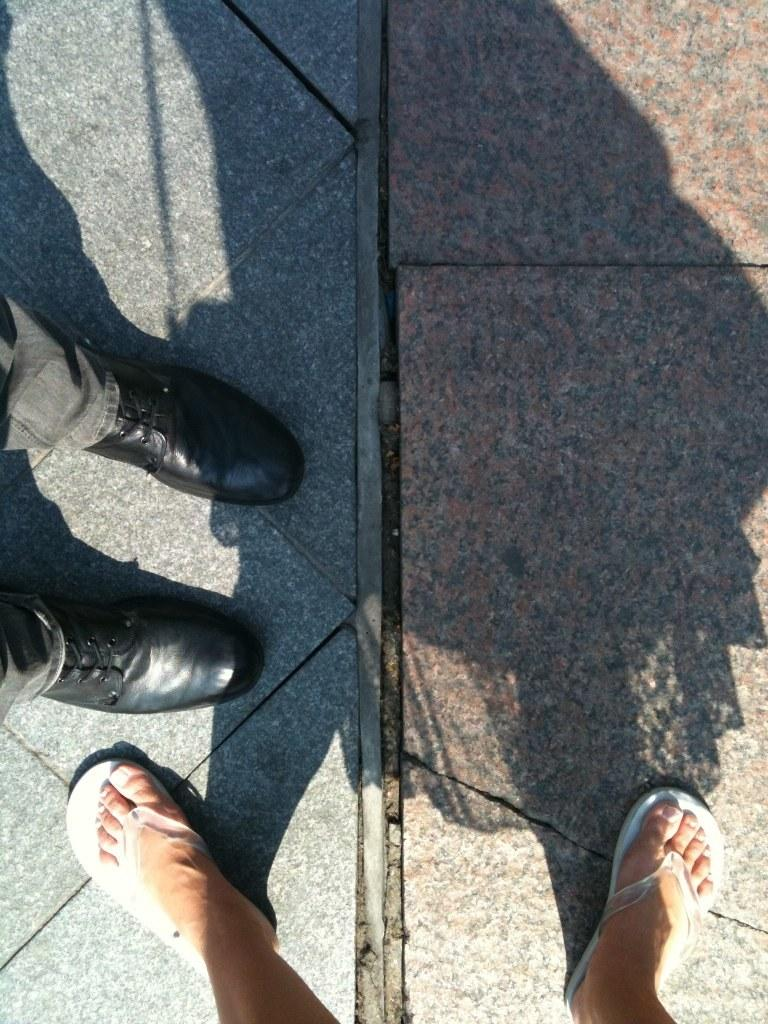What type of footwear is the man wearing in the image? The man is wearing black shoes in the image. What type of footwear is the woman wearing in the image? The woman is wearing slippers in the image. Can you describe any other features related to the woman in the image? Yes, there is a shadow of the woman in the image. How much money is being exchanged between the man and the woman in the image? There is no indication of any money exchange in the image; it only shows the legs of a man and a woman with their respective footwear. 